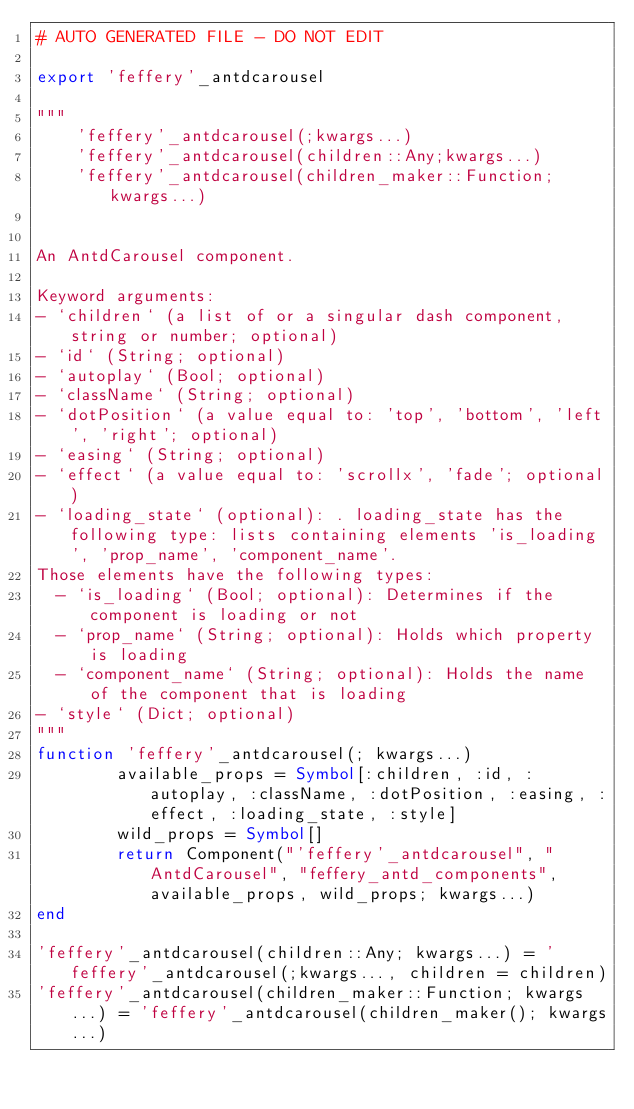Convert code to text. <code><loc_0><loc_0><loc_500><loc_500><_Julia_># AUTO GENERATED FILE - DO NOT EDIT

export 'feffery'_antdcarousel

"""
    'feffery'_antdcarousel(;kwargs...)
    'feffery'_antdcarousel(children::Any;kwargs...)
    'feffery'_antdcarousel(children_maker::Function;kwargs...)


An AntdCarousel component.

Keyword arguments:
- `children` (a list of or a singular dash component, string or number; optional)
- `id` (String; optional)
- `autoplay` (Bool; optional)
- `className` (String; optional)
- `dotPosition` (a value equal to: 'top', 'bottom', 'left', 'right'; optional)
- `easing` (String; optional)
- `effect` (a value equal to: 'scrollx', 'fade'; optional)
- `loading_state` (optional): . loading_state has the following type: lists containing elements 'is_loading', 'prop_name', 'component_name'.
Those elements have the following types:
  - `is_loading` (Bool; optional): Determines if the component is loading or not
  - `prop_name` (String; optional): Holds which property is loading
  - `component_name` (String; optional): Holds the name of the component that is loading
- `style` (Dict; optional)
"""
function 'feffery'_antdcarousel(; kwargs...)
        available_props = Symbol[:children, :id, :autoplay, :className, :dotPosition, :easing, :effect, :loading_state, :style]
        wild_props = Symbol[]
        return Component("'feffery'_antdcarousel", "AntdCarousel", "feffery_antd_components", available_props, wild_props; kwargs...)
end

'feffery'_antdcarousel(children::Any; kwargs...) = 'feffery'_antdcarousel(;kwargs..., children = children)
'feffery'_antdcarousel(children_maker::Function; kwargs...) = 'feffery'_antdcarousel(children_maker(); kwargs...)

</code> 